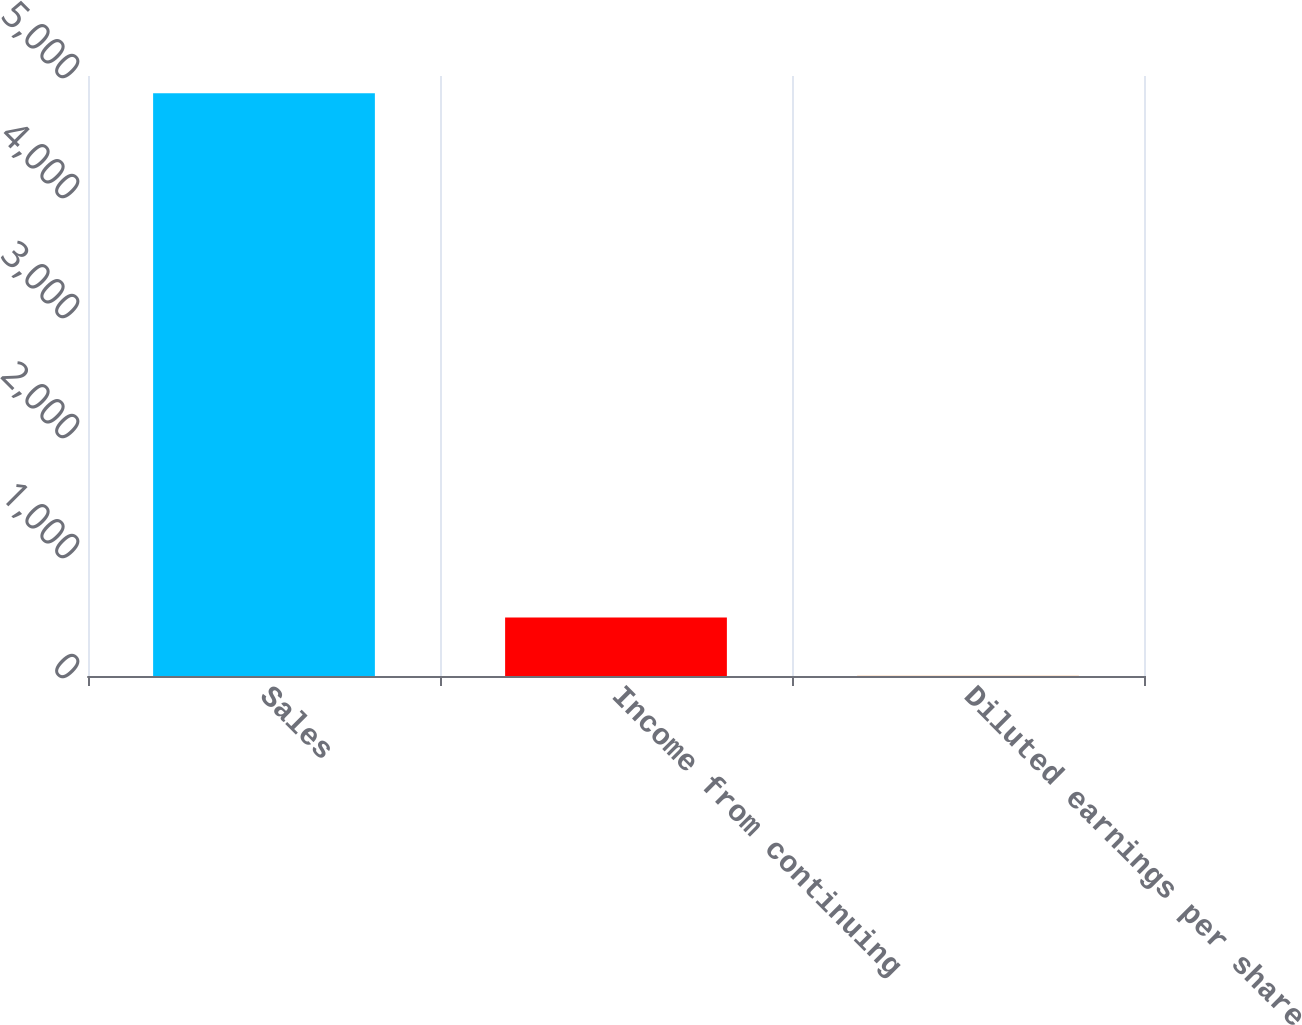<chart> <loc_0><loc_0><loc_500><loc_500><bar_chart><fcel>Sales<fcel>Income from continuing<fcel>Diluted earnings per share<nl><fcel>4857<fcel>488.44<fcel>3.05<nl></chart> 